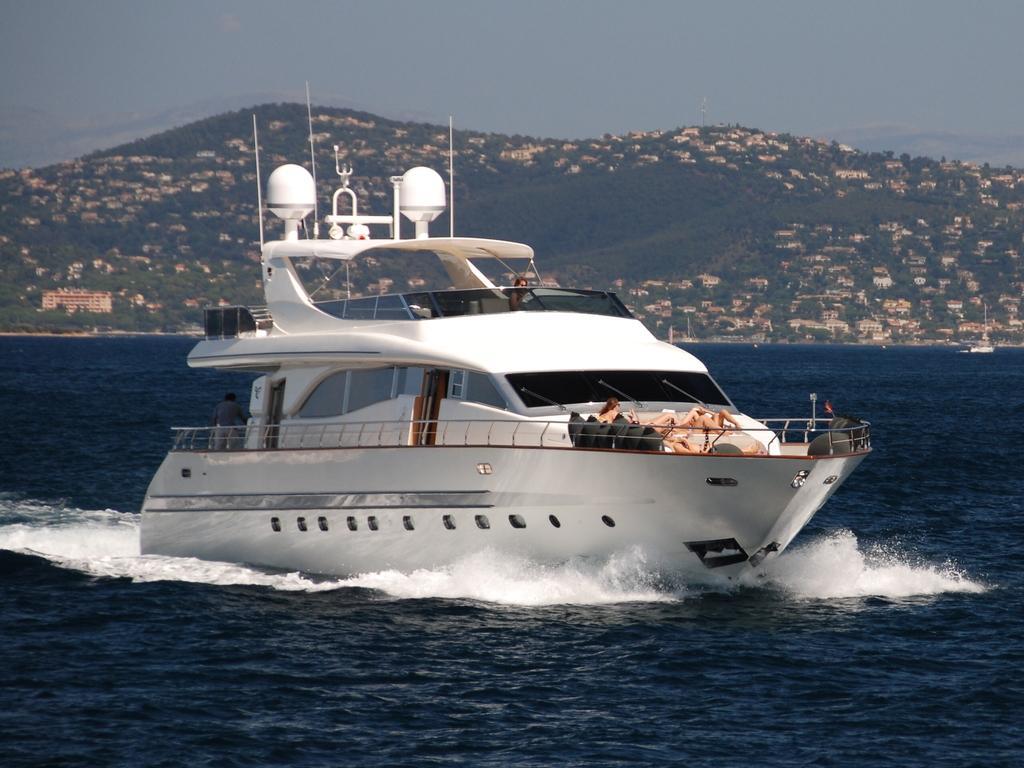Describe this image in one or two sentences. In this picture we can see a ship on water with some people on it, buildings, trees, mountains and in the background we can see the sky. 